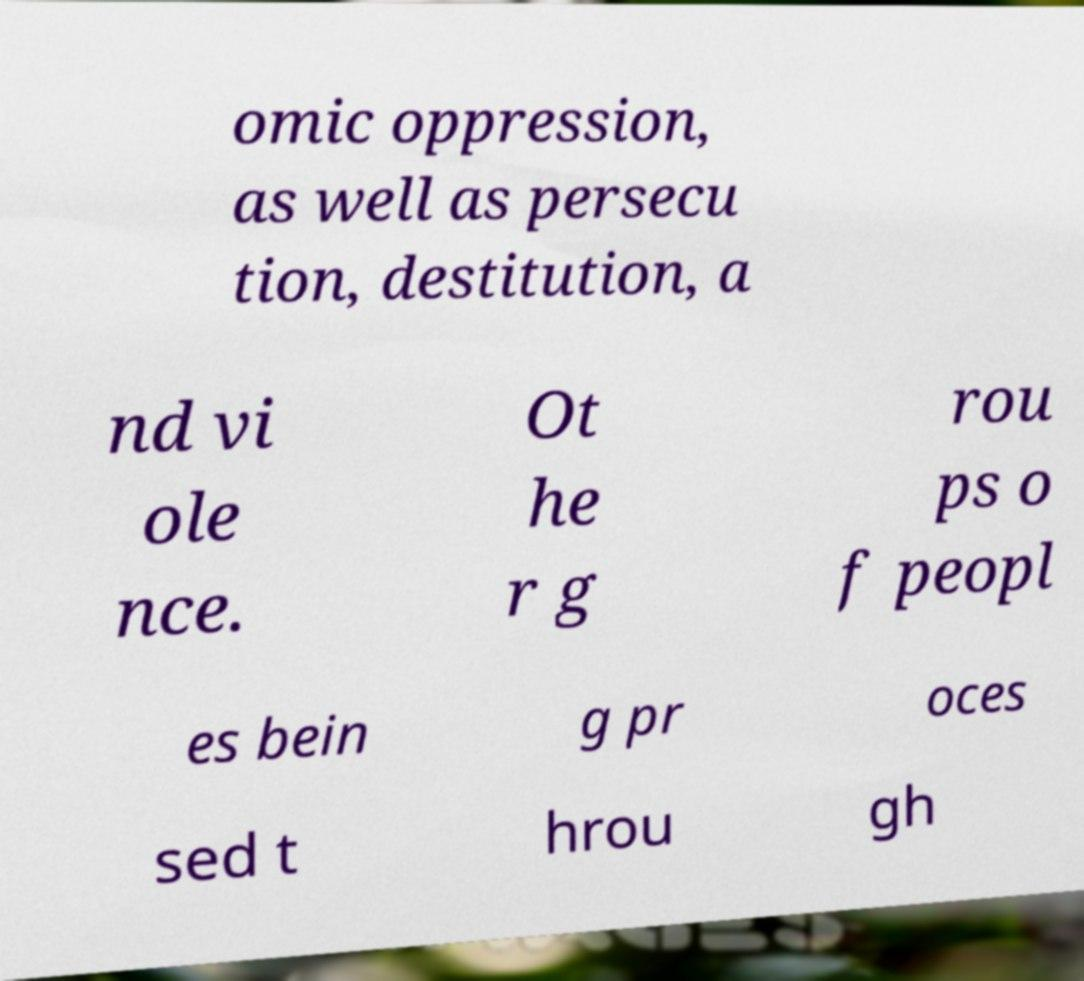There's text embedded in this image that I need extracted. Can you transcribe it verbatim? omic oppression, as well as persecu tion, destitution, a nd vi ole nce. Ot he r g rou ps o f peopl es bein g pr oces sed t hrou gh 